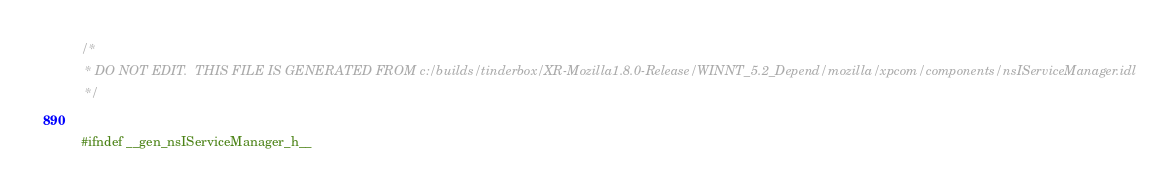Convert code to text. <code><loc_0><loc_0><loc_500><loc_500><_C_>/*
 * DO NOT EDIT.  THIS FILE IS GENERATED FROM c:/builds/tinderbox/XR-Mozilla1.8.0-Release/WINNT_5.2_Depend/mozilla/xpcom/components/nsIServiceManager.idl
 */

#ifndef __gen_nsIServiceManager_h__</code> 